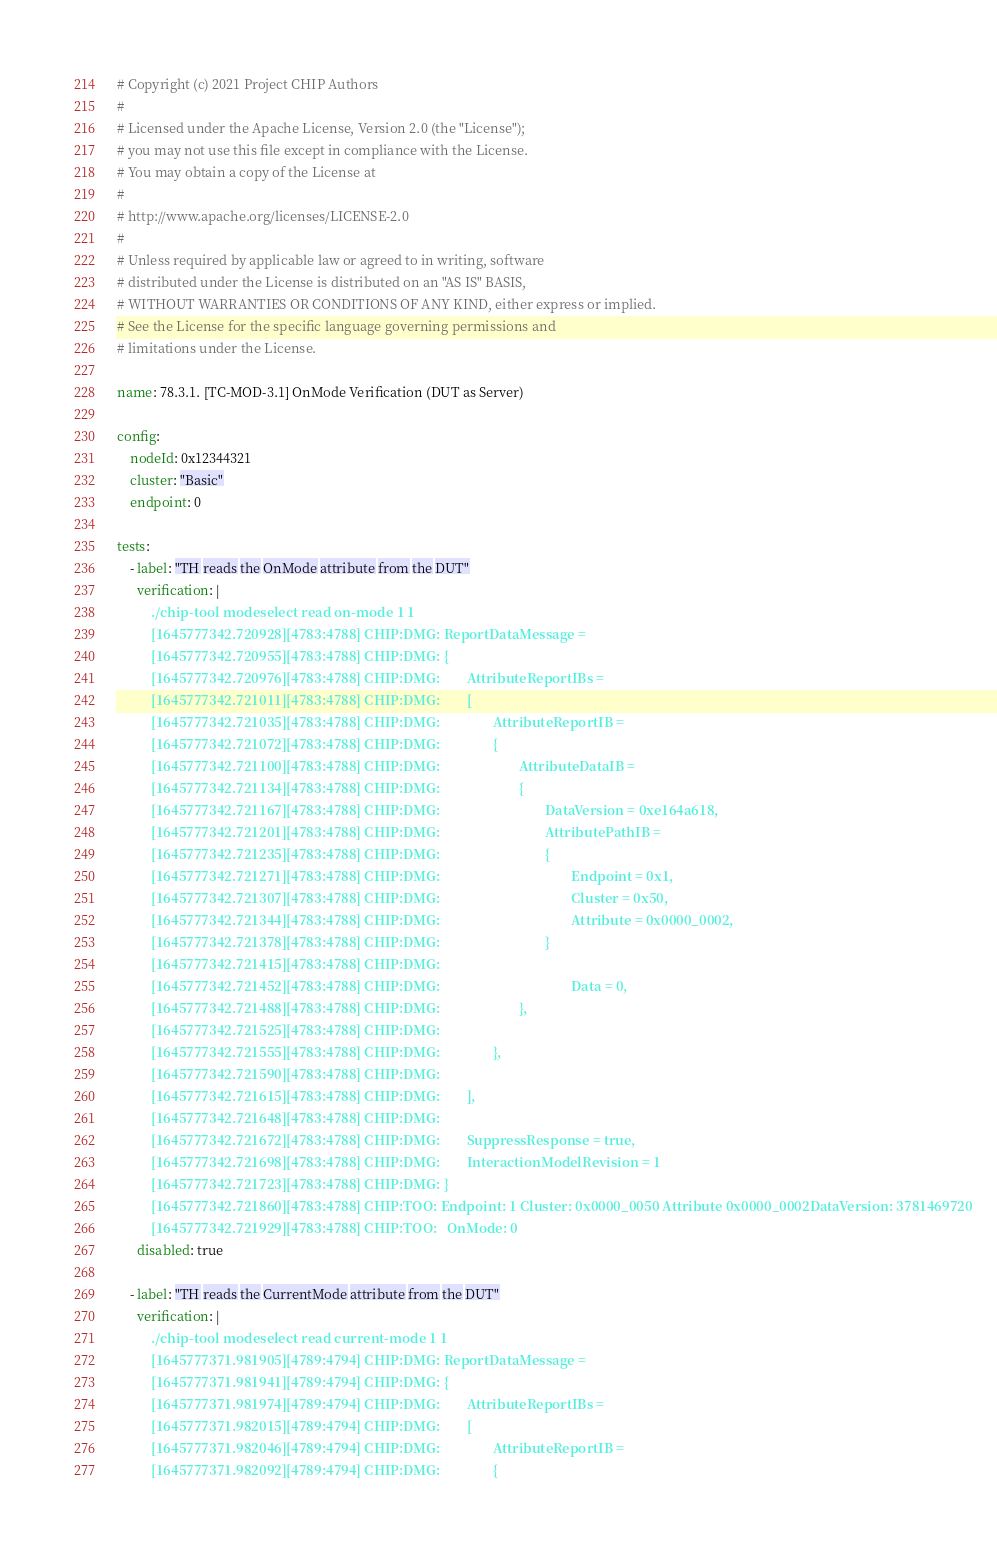Convert code to text. <code><loc_0><loc_0><loc_500><loc_500><_YAML_># Copyright (c) 2021 Project CHIP Authors
#
# Licensed under the Apache License, Version 2.0 (the "License");
# you may not use this file except in compliance with the License.
# You may obtain a copy of the License at
#
# http://www.apache.org/licenses/LICENSE-2.0
#
# Unless required by applicable law or agreed to in writing, software
# distributed under the License is distributed on an "AS IS" BASIS,
# WITHOUT WARRANTIES OR CONDITIONS OF ANY KIND, either express or implied.
# See the License for the specific language governing permissions and
# limitations under the License.

name: 78.3.1. [TC-MOD-3.1] OnMode Verification (DUT as Server)

config:
    nodeId: 0x12344321
    cluster: "Basic"
    endpoint: 0

tests:
    - label: "TH reads the OnMode attribute from the DUT"
      verification: |
          ./chip-tool modeselect read on-mode 1 1
          [1645777342.720928][4783:4788] CHIP:DMG: ReportDataMessage =
          [1645777342.720955][4783:4788] CHIP:DMG: {
          [1645777342.720976][4783:4788] CHIP:DMG:        AttributeReportIBs =
          [1645777342.721011][4783:4788] CHIP:DMG:        [
          [1645777342.721035][4783:4788] CHIP:DMG:                AttributeReportIB =
          [1645777342.721072][4783:4788] CHIP:DMG:                {
          [1645777342.721100][4783:4788] CHIP:DMG:                        AttributeDataIB =
          [1645777342.721134][4783:4788] CHIP:DMG:                        {
          [1645777342.721167][4783:4788] CHIP:DMG:                                DataVersion = 0xe164a618,
          [1645777342.721201][4783:4788] CHIP:DMG:                                AttributePathIB =
          [1645777342.721235][4783:4788] CHIP:DMG:                                {
          [1645777342.721271][4783:4788] CHIP:DMG:                                        Endpoint = 0x1,
          [1645777342.721307][4783:4788] CHIP:DMG:                                        Cluster = 0x50,
          [1645777342.721344][4783:4788] CHIP:DMG:                                        Attribute = 0x0000_0002,
          [1645777342.721378][4783:4788] CHIP:DMG:                                }
          [1645777342.721415][4783:4788] CHIP:DMG:
          [1645777342.721452][4783:4788] CHIP:DMG:                                        Data = 0,
          [1645777342.721488][4783:4788] CHIP:DMG:                        },
          [1645777342.721525][4783:4788] CHIP:DMG:
          [1645777342.721555][4783:4788] CHIP:DMG:                },
          [1645777342.721590][4783:4788] CHIP:DMG:
          [1645777342.721615][4783:4788] CHIP:DMG:        ],
          [1645777342.721648][4783:4788] CHIP:DMG:
          [1645777342.721672][4783:4788] CHIP:DMG:        SuppressResponse = true,
          [1645777342.721698][4783:4788] CHIP:DMG:        InteractionModelRevision = 1
          [1645777342.721723][4783:4788] CHIP:DMG: }
          [1645777342.721860][4783:4788] CHIP:TOO: Endpoint: 1 Cluster: 0x0000_0050 Attribute 0x0000_0002DataVersion: 3781469720
          [1645777342.721929][4783:4788] CHIP:TOO:   OnMode: 0
      disabled: true

    - label: "TH reads the CurrentMode attribute from the DUT"
      verification: |
          ./chip-tool modeselect read current-mode 1 1
          [1645777371.981905][4789:4794] CHIP:DMG: ReportDataMessage =
          [1645777371.981941][4789:4794] CHIP:DMG: {
          [1645777371.981974][4789:4794] CHIP:DMG:        AttributeReportIBs =
          [1645777371.982015][4789:4794] CHIP:DMG:        [
          [1645777371.982046][4789:4794] CHIP:DMG:                AttributeReportIB =
          [1645777371.982092][4789:4794] CHIP:DMG:                {</code> 